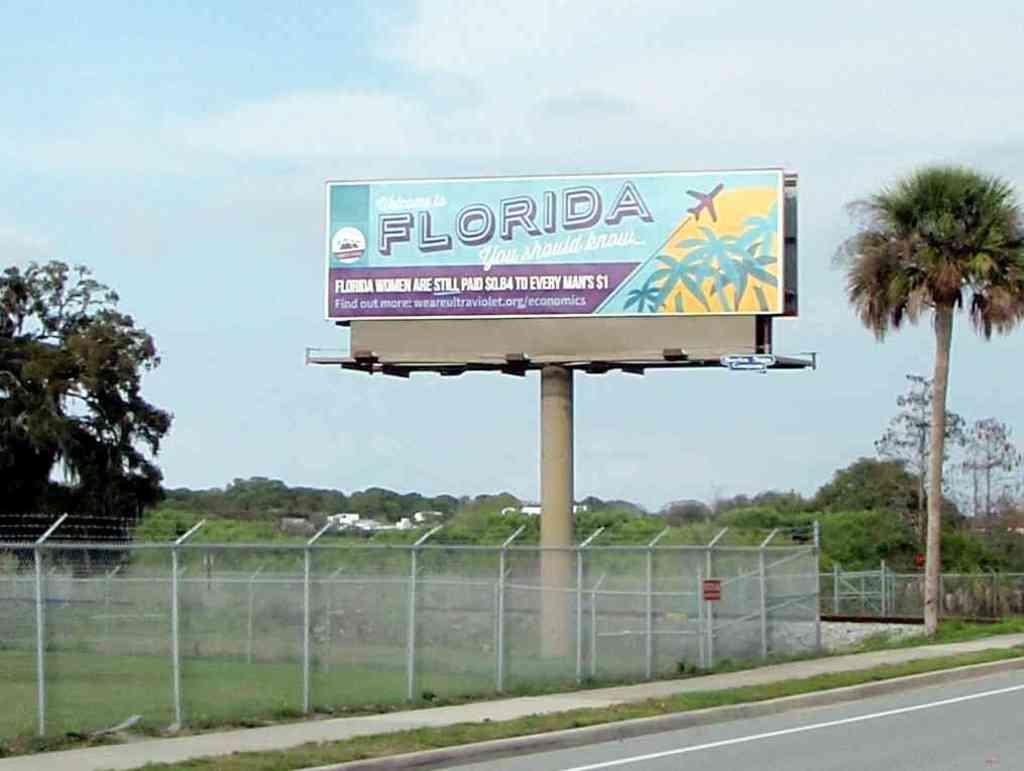<image>
Relay a brief, clear account of the picture shown. A billboard about women in Florida is next to a palm tree. 